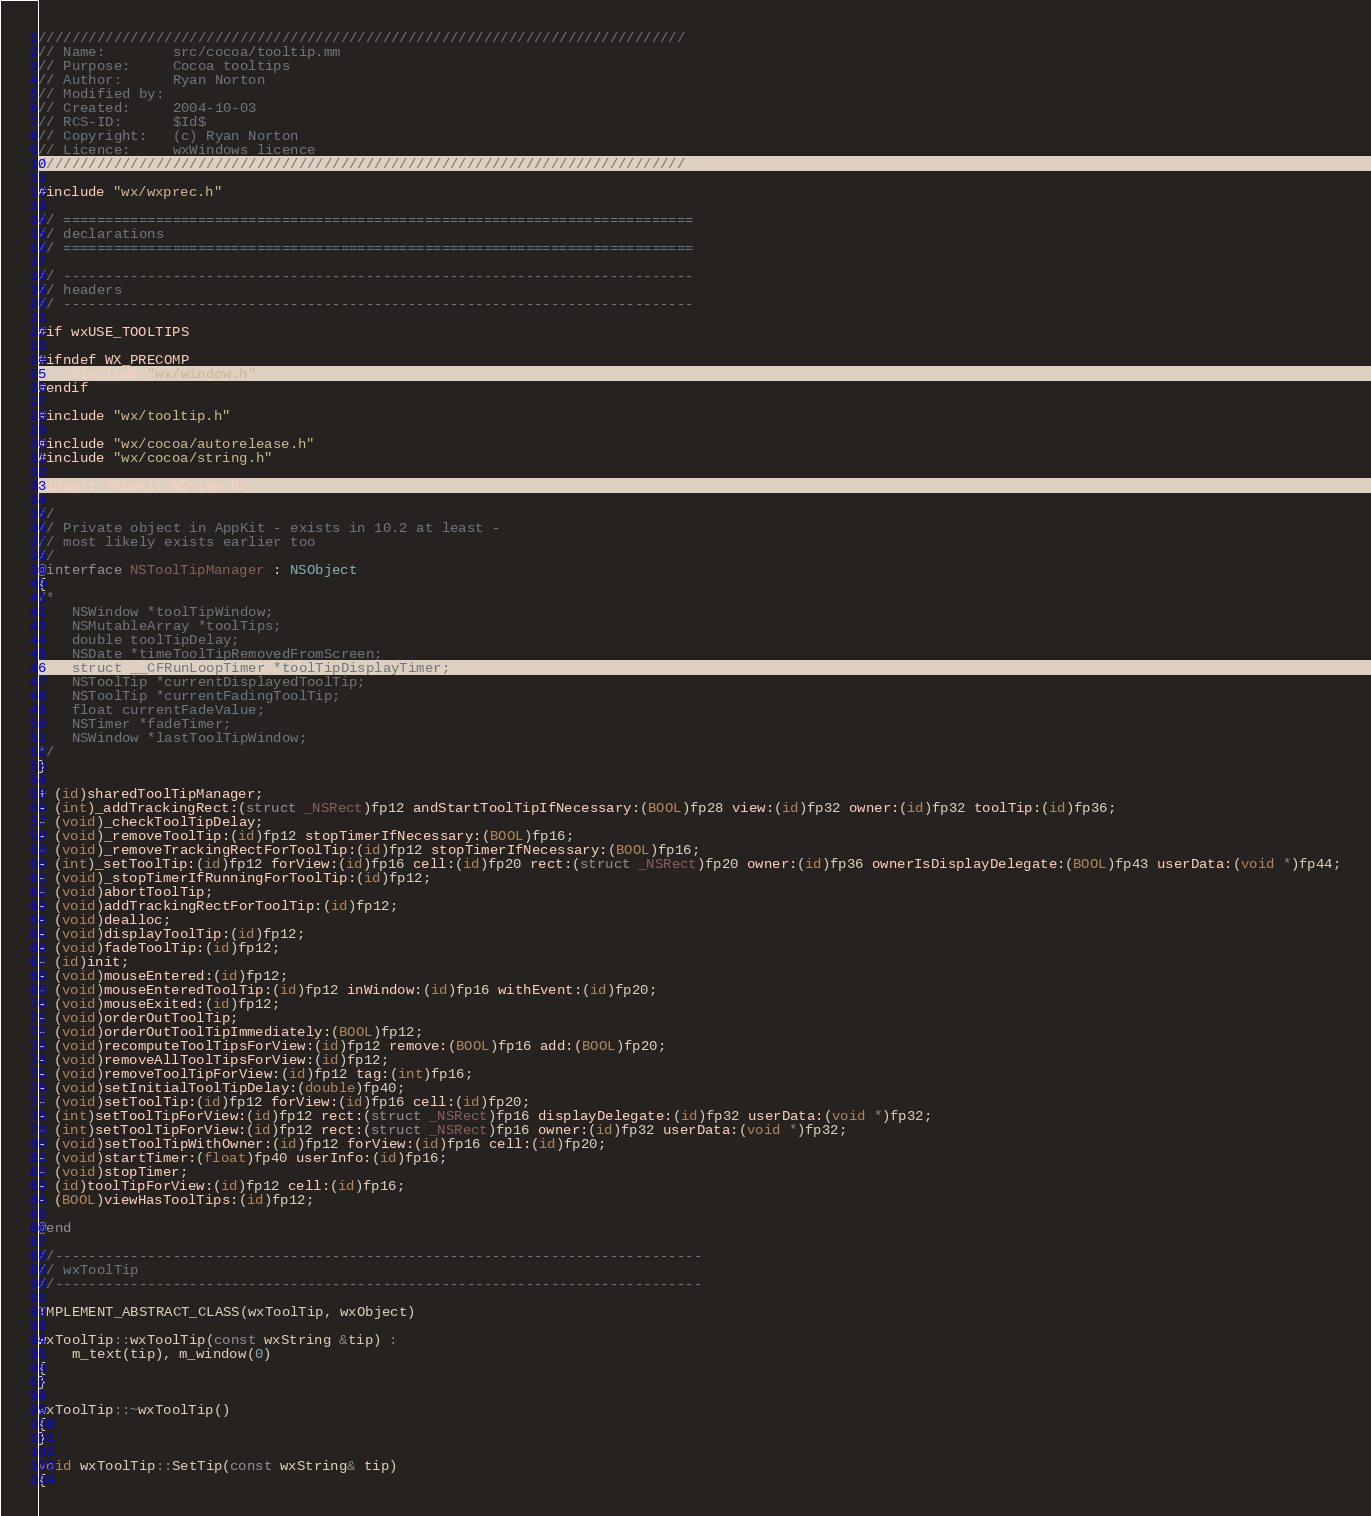<code> <loc_0><loc_0><loc_500><loc_500><_ObjectiveC_>/////////////////////////////////////////////////////////////////////////////
// Name:        src/cocoa/tooltip.mm
// Purpose:     Cocoa tooltips
// Author:      Ryan Norton
// Modified by:
// Created:     2004-10-03
// RCS-ID:      $Id$
// Copyright:   (c) Ryan Norton
// Licence:     wxWindows licence
/////////////////////////////////////////////////////////////////////////////

#include "wx/wxprec.h"

// ===========================================================================
// declarations
// ===========================================================================

// ---------------------------------------------------------------------------
// headers
// ---------------------------------------------------------------------------

#if wxUSE_TOOLTIPS

#ifndef WX_PRECOMP
    #include "wx/window.h"
#endif

#include "wx/tooltip.h"

#include "wx/cocoa/autorelease.h"
#include "wx/cocoa/string.h"

#import <AppKit/NSView.h>

//
// Private object in AppKit - exists in 10.2 at least -
// most likely exists earlier too
//
@interface NSToolTipManager : NSObject
{
/*
    NSWindow *toolTipWindow;
    NSMutableArray *toolTips;
    double toolTipDelay;
    NSDate *timeToolTipRemovedFromScreen;
    struct __CFRunLoopTimer *toolTipDisplayTimer;
    NSToolTip *currentDisplayedToolTip;
    NSToolTip *currentFadingToolTip;
    float currentFadeValue;
    NSTimer *fadeTimer;
    NSWindow *lastToolTipWindow;
*/
}

+ (id)sharedToolTipManager;
- (int)_addTrackingRect:(struct _NSRect)fp12 andStartToolTipIfNecessary:(BOOL)fp28 view:(id)fp32 owner:(id)fp32 toolTip:(id)fp36;
- (void)_checkToolTipDelay;
- (void)_removeToolTip:(id)fp12 stopTimerIfNecessary:(BOOL)fp16;
- (void)_removeTrackingRectForToolTip:(id)fp12 stopTimerIfNecessary:(BOOL)fp16;
- (int)_setToolTip:(id)fp12 forView:(id)fp16 cell:(id)fp20 rect:(struct _NSRect)fp20 owner:(id)fp36 ownerIsDisplayDelegate:(BOOL)fp43 userData:(void *)fp44;
- (void)_stopTimerIfRunningForToolTip:(id)fp12;
- (void)abortToolTip;
- (void)addTrackingRectForToolTip:(id)fp12;
- (void)dealloc;
- (void)displayToolTip:(id)fp12;
- (void)fadeToolTip:(id)fp12;
- (id)init;
- (void)mouseEntered:(id)fp12;
- (void)mouseEnteredToolTip:(id)fp12 inWindow:(id)fp16 withEvent:(id)fp20;
- (void)mouseExited:(id)fp12;
- (void)orderOutToolTip;
- (void)orderOutToolTipImmediately:(BOOL)fp12;
- (void)recomputeToolTipsForView:(id)fp12 remove:(BOOL)fp16 add:(BOOL)fp20;
- (void)removeAllToolTipsForView:(id)fp12;
- (void)removeToolTipForView:(id)fp12 tag:(int)fp16;
- (void)setInitialToolTipDelay:(double)fp40;
- (void)setToolTip:(id)fp12 forView:(id)fp16 cell:(id)fp20;
- (int)setToolTipForView:(id)fp12 rect:(struct _NSRect)fp16 displayDelegate:(id)fp32 userData:(void *)fp32;
- (int)setToolTipForView:(id)fp12 rect:(struct _NSRect)fp16 owner:(id)fp32 userData:(void *)fp32;
- (void)setToolTipWithOwner:(id)fp12 forView:(id)fp16 cell:(id)fp20;
- (void)startTimer:(float)fp40 userInfo:(id)fp16;
- (void)stopTimer;
- (id)toolTipForView:(id)fp12 cell:(id)fp16;
- (BOOL)viewHasToolTips:(id)fp12;

@end

//-----------------------------------------------------------------------------
// wxToolTip
//-----------------------------------------------------------------------------

IMPLEMENT_ABSTRACT_CLASS(wxToolTip, wxObject)

wxToolTip::wxToolTip(const wxString &tip) :
    m_text(tip), m_window(0)
{
}

wxToolTip::~wxToolTip()
{
}

void wxToolTip::SetTip(const wxString& tip)
{</code> 